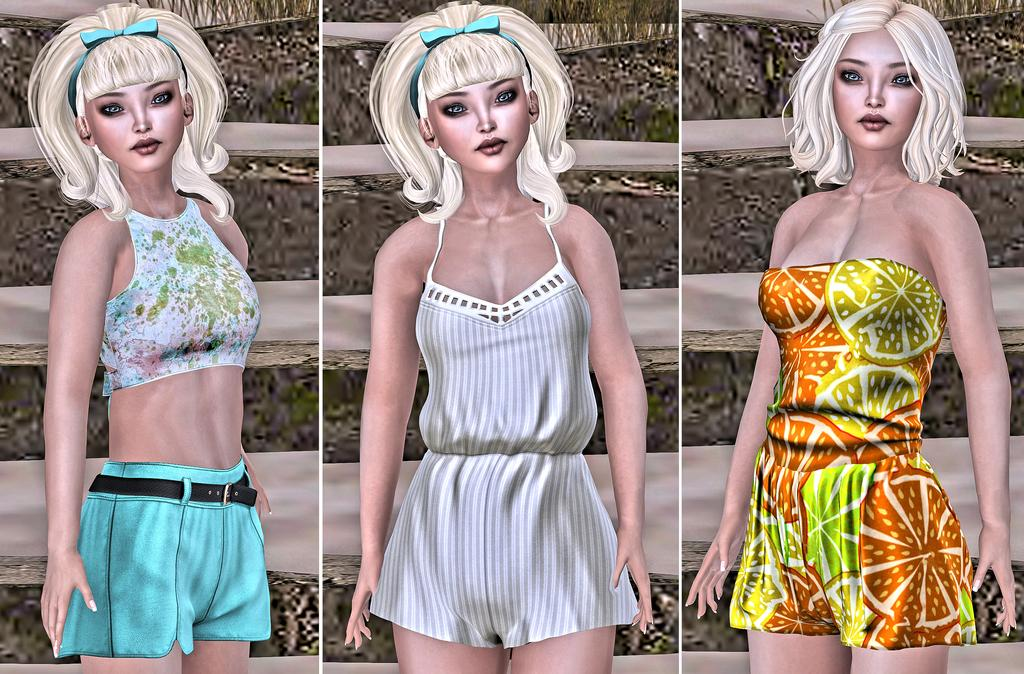How many girls are featured in the image? The image is a collage of three girls. Can you describe the composition of the image? The image is a collage, which means it is composed of multiple smaller images or elements. In this case, the collage consists of three girls. What type of bean is present in the image? There are no beans present in the image; it features a collage of three girls. How does the image increase in size when viewed on a larger screen? The image itself does not increase in size when viewed on a larger screen; it maintains its original dimensions. 